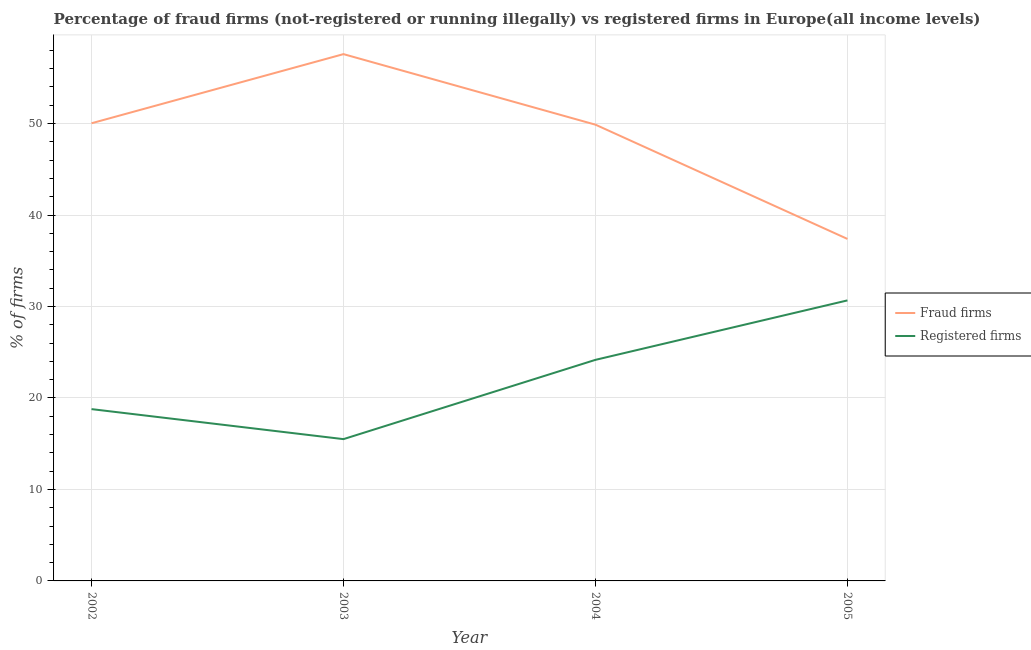How many different coloured lines are there?
Provide a short and direct response. 2. Does the line corresponding to percentage of fraud firms intersect with the line corresponding to percentage of registered firms?
Your response must be concise. No. What is the percentage of registered firms in 2004?
Offer a very short reply. 24.17. Across all years, what is the maximum percentage of fraud firms?
Provide a short and direct response. 57.59. In which year was the percentage of registered firms maximum?
Provide a short and direct response. 2005. What is the total percentage of registered firms in the graph?
Give a very brief answer. 89.11. What is the difference between the percentage of registered firms in 2002 and that in 2004?
Give a very brief answer. -5.39. What is the difference between the percentage of fraud firms in 2004 and the percentage of registered firms in 2003?
Your answer should be compact. 34.38. What is the average percentage of fraud firms per year?
Provide a succinct answer. 48.72. In the year 2002, what is the difference between the percentage of registered firms and percentage of fraud firms?
Keep it short and to the point. -31.25. What is the ratio of the percentage of fraud firms in 2002 to that in 2005?
Make the answer very short. 1.34. Is the difference between the percentage of fraud firms in 2002 and 2004 greater than the difference between the percentage of registered firms in 2002 and 2004?
Provide a succinct answer. Yes. What is the difference between the highest and the second highest percentage of registered firms?
Offer a terse response. 6.5. What is the difference between the highest and the lowest percentage of registered firms?
Make the answer very short. 15.17. Is the percentage of fraud firms strictly less than the percentage of registered firms over the years?
Your answer should be very brief. No. Are the values on the major ticks of Y-axis written in scientific E-notation?
Your response must be concise. No. Does the graph contain grids?
Provide a succinct answer. Yes. Where does the legend appear in the graph?
Your answer should be compact. Center right. How many legend labels are there?
Your response must be concise. 2. How are the legend labels stacked?
Your answer should be compact. Vertical. What is the title of the graph?
Keep it short and to the point. Percentage of fraud firms (not-registered or running illegally) vs registered firms in Europe(all income levels). Does "Manufacturing industries and construction" appear as one of the legend labels in the graph?
Offer a terse response. No. What is the label or title of the X-axis?
Keep it short and to the point. Year. What is the label or title of the Y-axis?
Keep it short and to the point. % of firms. What is the % of firms of Fraud firms in 2002?
Offer a very short reply. 50.03. What is the % of firms in Registered firms in 2002?
Your response must be concise. 18.78. What is the % of firms of Fraud firms in 2003?
Provide a short and direct response. 57.59. What is the % of firms of Registered firms in 2003?
Ensure brevity in your answer.  15.5. What is the % of firms of Fraud firms in 2004?
Give a very brief answer. 49.88. What is the % of firms of Registered firms in 2004?
Your answer should be compact. 24.17. What is the % of firms in Fraud firms in 2005?
Provide a short and direct response. 37.39. What is the % of firms in Registered firms in 2005?
Keep it short and to the point. 30.67. Across all years, what is the maximum % of firms of Fraud firms?
Offer a terse response. 57.59. Across all years, what is the maximum % of firms in Registered firms?
Give a very brief answer. 30.67. Across all years, what is the minimum % of firms in Fraud firms?
Provide a short and direct response. 37.39. What is the total % of firms of Fraud firms in the graph?
Your answer should be compact. 194.88. What is the total % of firms of Registered firms in the graph?
Your response must be concise. 89.11. What is the difference between the % of firms of Fraud firms in 2002 and that in 2003?
Offer a very short reply. -7.56. What is the difference between the % of firms in Registered firms in 2002 and that in 2003?
Offer a very short reply. 3.28. What is the difference between the % of firms in Fraud firms in 2002 and that in 2004?
Keep it short and to the point. 0.15. What is the difference between the % of firms in Registered firms in 2002 and that in 2004?
Keep it short and to the point. -5.39. What is the difference between the % of firms in Fraud firms in 2002 and that in 2005?
Keep it short and to the point. 12.64. What is the difference between the % of firms in Registered firms in 2002 and that in 2005?
Make the answer very short. -11.88. What is the difference between the % of firms in Fraud firms in 2003 and that in 2004?
Provide a short and direct response. 7.71. What is the difference between the % of firms in Registered firms in 2003 and that in 2004?
Provide a short and direct response. -8.67. What is the difference between the % of firms in Fraud firms in 2003 and that in 2005?
Provide a short and direct response. 20.2. What is the difference between the % of firms in Registered firms in 2003 and that in 2005?
Keep it short and to the point. -15.17. What is the difference between the % of firms of Fraud firms in 2004 and that in 2005?
Ensure brevity in your answer.  12.49. What is the difference between the % of firms in Registered firms in 2004 and that in 2005?
Keep it short and to the point. -6.5. What is the difference between the % of firms in Fraud firms in 2002 and the % of firms in Registered firms in 2003?
Give a very brief answer. 34.53. What is the difference between the % of firms of Fraud firms in 2002 and the % of firms of Registered firms in 2004?
Your answer should be compact. 25.86. What is the difference between the % of firms of Fraud firms in 2002 and the % of firms of Registered firms in 2005?
Your response must be concise. 19.36. What is the difference between the % of firms in Fraud firms in 2003 and the % of firms in Registered firms in 2004?
Keep it short and to the point. 33.42. What is the difference between the % of firms in Fraud firms in 2003 and the % of firms in Registered firms in 2005?
Provide a succinct answer. 26.92. What is the difference between the % of firms in Fraud firms in 2004 and the % of firms in Registered firms in 2005?
Your response must be concise. 19.21. What is the average % of firms of Fraud firms per year?
Provide a succinct answer. 48.72. What is the average % of firms in Registered firms per year?
Offer a very short reply. 22.28. In the year 2002, what is the difference between the % of firms of Fraud firms and % of firms of Registered firms?
Keep it short and to the point. 31.25. In the year 2003, what is the difference between the % of firms of Fraud firms and % of firms of Registered firms?
Ensure brevity in your answer.  42.09. In the year 2004, what is the difference between the % of firms in Fraud firms and % of firms in Registered firms?
Provide a short and direct response. 25.71. In the year 2005, what is the difference between the % of firms of Fraud firms and % of firms of Registered firms?
Offer a very short reply. 6.72. What is the ratio of the % of firms of Fraud firms in 2002 to that in 2003?
Provide a short and direct response. 0.87. What is the ratio of the % of firms of Registered firms in 2002 to that in 2003?
Offer a terse response. 1.21. What is the ratio of the % of firms in Registered firms in 2002 to that in 2004?
Your answer should be compact. 0.78. What is the ratio of the % of firms of Fraud firms in 2002 to that in 2005?
Your answer should be compact. 1.34. What is the ratio of the % of firms of Registered firms in 2002 to that in 2005?
Your response must be concise. 0.61. What is the ratio of the % of firms of Fraud firms in 2003 to that in 2004?
Give a very brief answer. 1.15. What is the ratio of the % of firms of Registered firms in 2003 to that in 2004?
Provide a succinct answer. 0.64. What is the ratio of the % of firms of Fraud firms in 2003 to that in 2005?
Your response must be concise. 1.54. What is the ratio of the % of firms of Registered firms in 2003 to that in 2005?
Ensure brevity in your answer.  0.51. What is the ratio of the % of firms of Fraud firms in 2004 to that in 2005?
Provide a short and direct response. 1.33. What is the ratio of the % of firms of Registered firms in 2004 to that in 2005?
Your answer should be very brief. 0.79. What is the difference between the highest and the second highest % of firms of Fraud firms?
Offer a very short reply. 7.56. What is the difference between the highest and the second highest % of firms in Registered firms?
Provide a succinct answer. 6.5. What is the difference between the highest and the lowest % of firms in Fraud firms?
Keep it short and to the point. 20.2. What is the difference between the highest and the lowest % of firms of Registered firms?
Your answer should be compact. 15.17. 